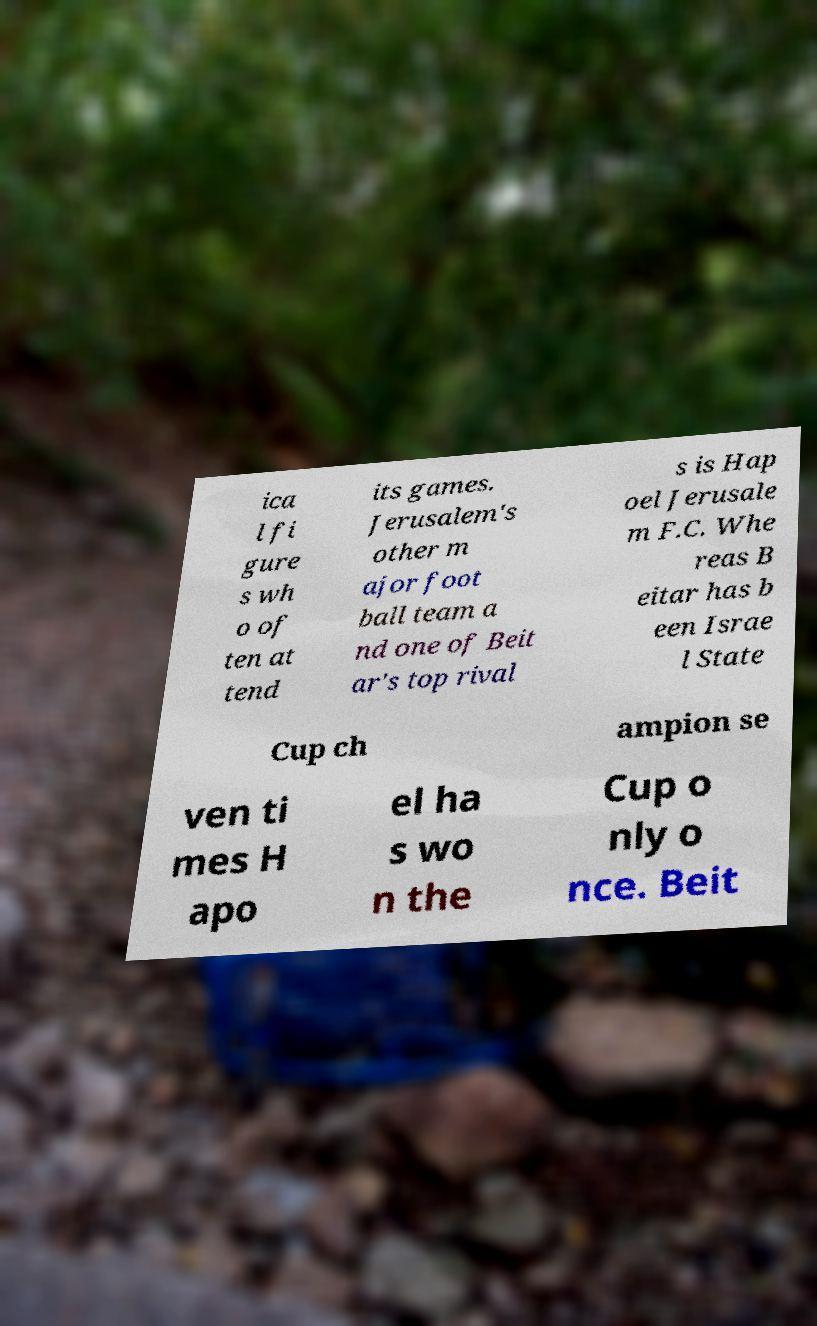Can you read and provide the text displayed in the image?This photo seems to have some interesting text. Can you extract and type it out for me? ica l fi gure s wh o of ten at tend its games. Jerusalem's other m ajor foot ball team a nd one of Beit ar's top rival s is Hap oel Jerusale m F.C. Whe reas B eitar has b een Israe l State Cup ch ampion se ven ti mes H apo el ha s wo n the Cup o nly o nce. Beit 